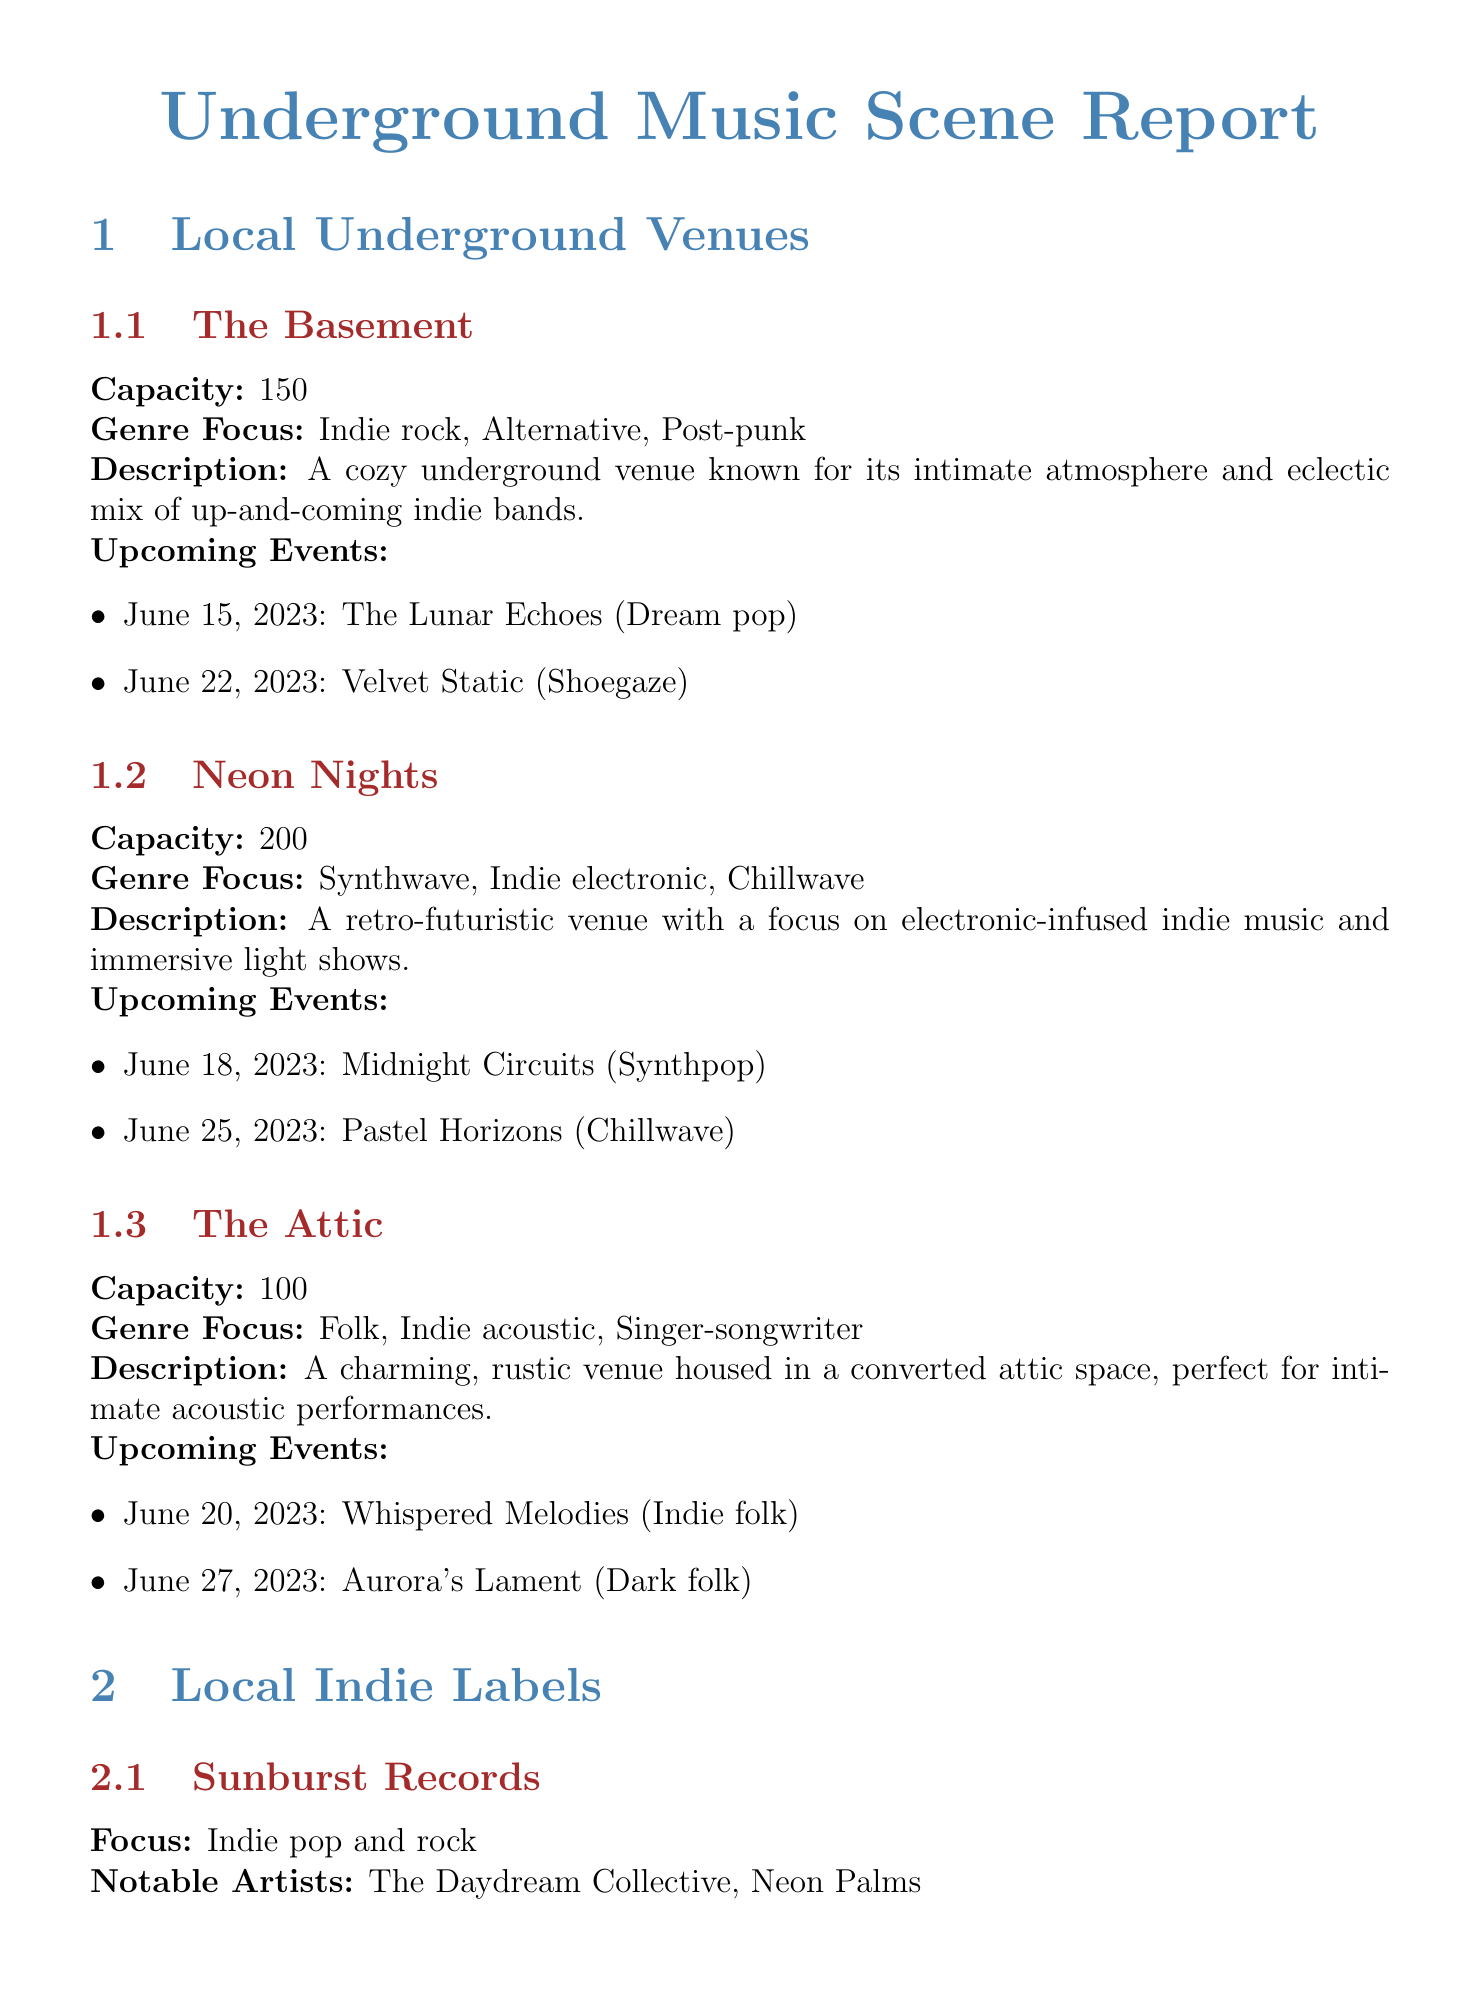What is the capacity of The Basement? The capacity is mentioned directly under the venue's details as a specific number.
Answer: 150 Which genre does Neon Nights focus on? The genre focus is listed for each venue, and Neon Nights features three genres.
Answer: Synthwave, Indie electronic, Chillwave What is the upcoming event at The Attic on June 20, 2023? The document provides a list of upcoming events for each venue with specific dates.
Answer: Whispered Melodies (Indie folk) How many notable artists are listed for Sunburst Records? The notable artists for each label are enumerated, allowing for a straightforward count.
Answer: 2 What is the date range for the SoundWave Festival? The festival dates are provided as a clear period in the festival's details section.
Answer: August 12-14, 2023 Which indie music blog is dedicated to promoting local talent? The description of each blog includes its specific focus, identifying the one centered on local talent.
Answer: Alternative Frequencies What time does Midnight Melodies air on Saturdays? The air time is explicitly stated in the radio show section of the document.
Answer: 10 PM - 12 AM How many venues are detailed in the report? The list of underground venues can be directly counted from the document.
Answer: 3 What is the focus of Midnight Echo Productions? The focus of each local indie label is stated clearly in their respective sections.
Answer: Electronic and experimental 